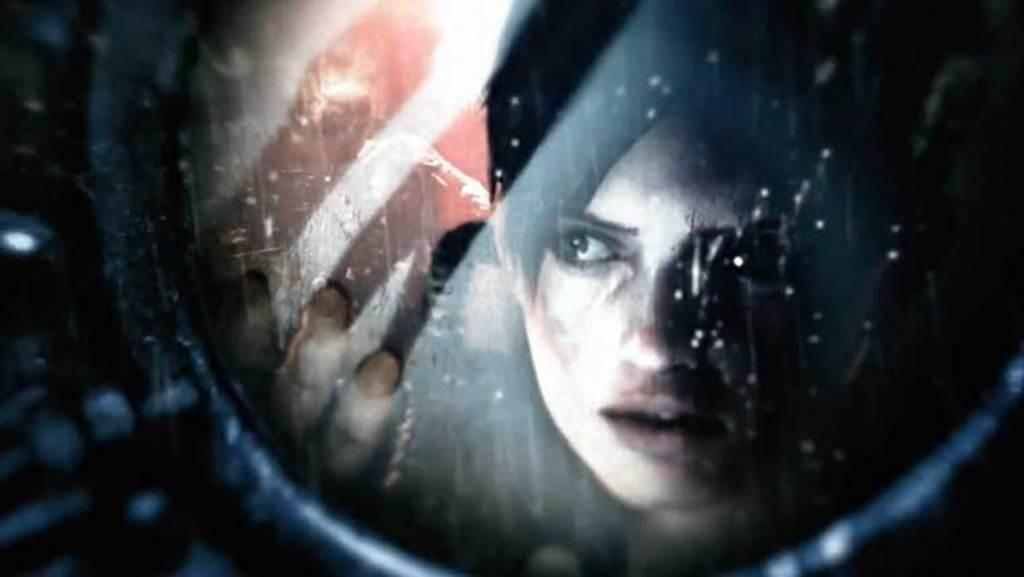Who is the main subject in the image? There is a girl in the image. Where is the girl located in the image? The girl is on the right side of the image. What type of hat is the animal wearing in the image? There is no animal or hat present in the image; it only features a girl. 